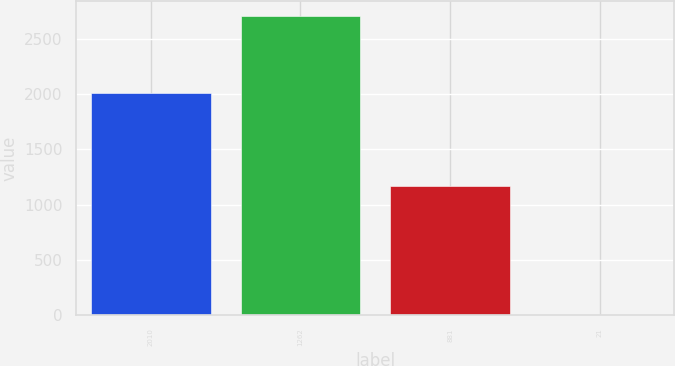<chart> <loc_0><loc_0><loc_500><loc_500><bar_chart><fcel>2010<fcel>1262<fcel>881<fcel>21<nl><fcel>2009<fcel>2712<fcel>1167<fcel>3.2<nl></chart> 